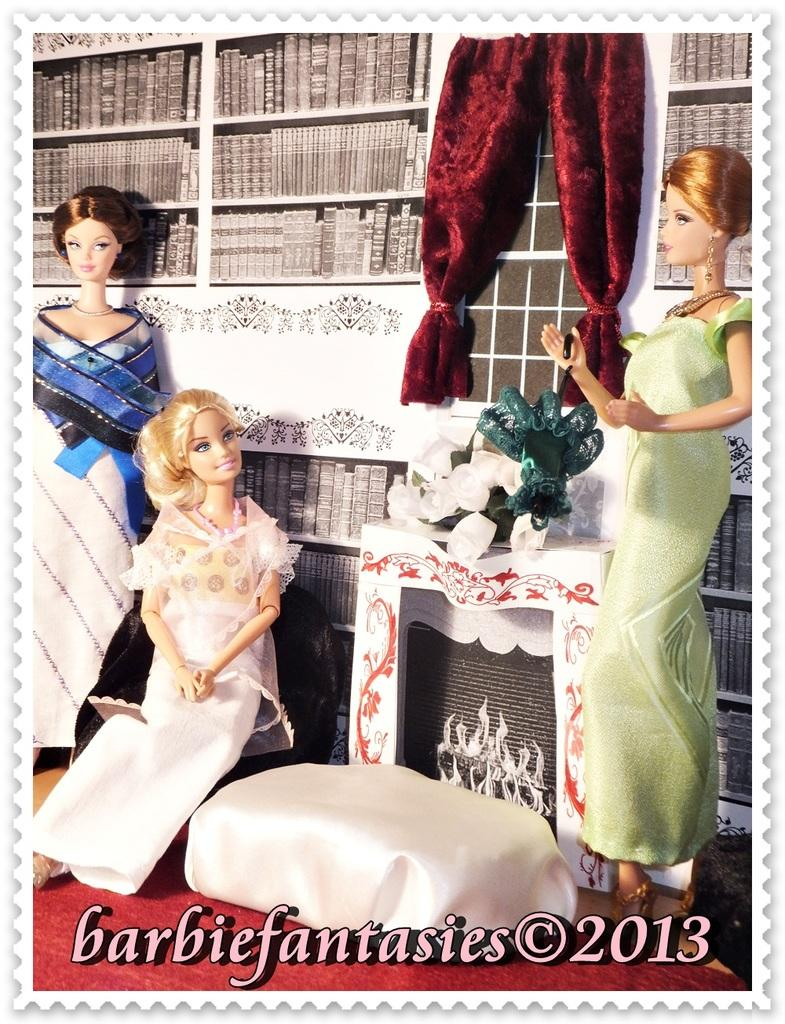What is the main subject of the poster in the image? The main subject of the poster in the image is "Barbie Fantasies." How many people are shown making a decision in the image? There are no people shown making a decision in the image; it only features a "Barbie Fantasies" poster. 